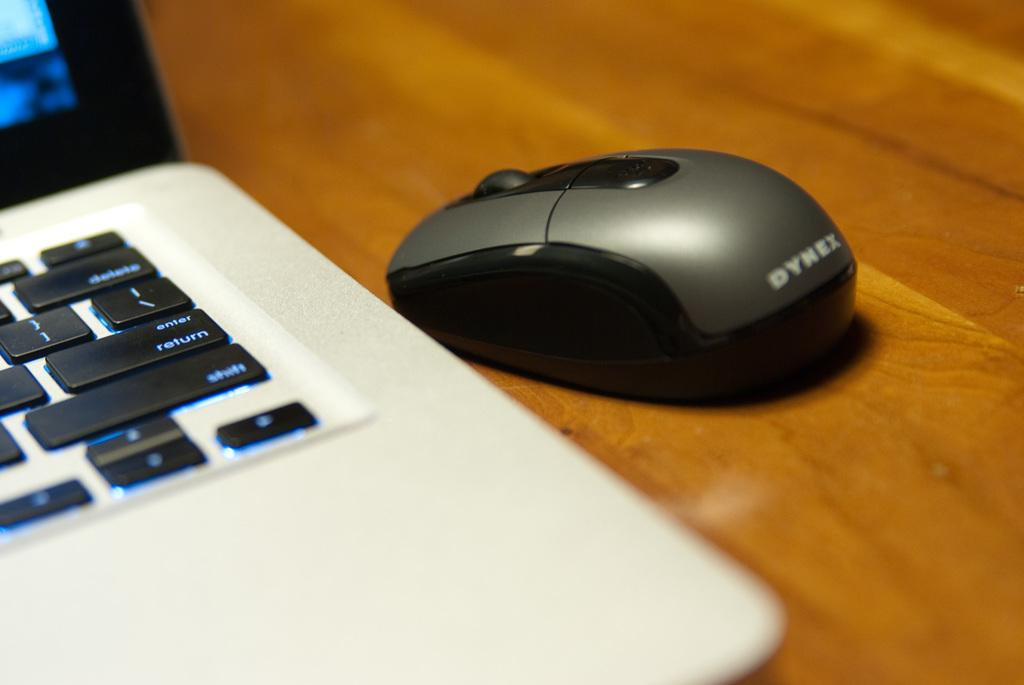<image>
Provide a brief description of the given image. A small Dynex brand wireless mouse next to an open laptop. 